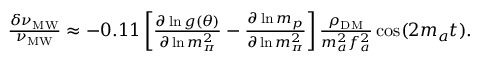Convert formula to latex. <formula><loc_0><loc_0><loc_500><loc_500>\begin{array} { r } { \frac { \delta \nu _ { M W } } { \nu _ { M W } } \approx - 0 . 1 1 \left [ \frac { \partial \ln g ( \theta ) } { \partial \ln m _ { \pi } ^ { 2 } } - \frac { \partial \ln m _ { p } } { \partial \ln m _ { \pi } ^ { 2 } } \right ] \frac { \rho _ { D M } } { m _ { a } ^ { 2 } f _ { a } ^ { 2 } } \cos ( 2 m _ { a } t ) . } \end{array}</formula> 